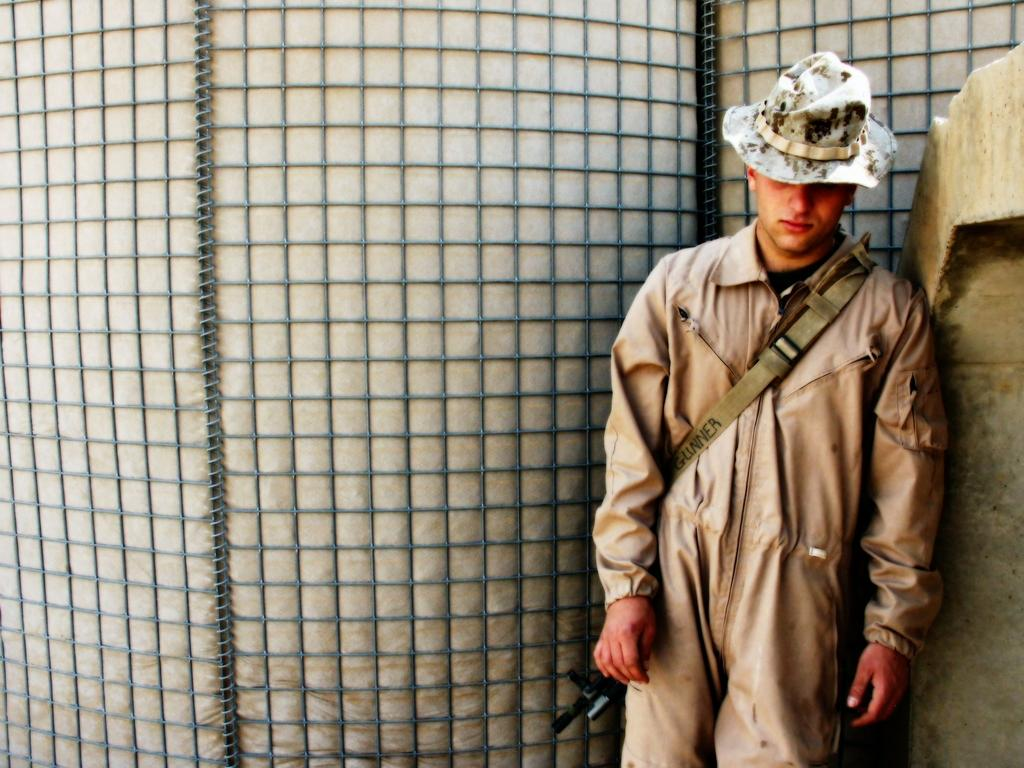Who or what is present in the image? There is a person in the image. What is the person wearing on their head? The person is wearing a hat. What can be seen on the right side of the image? There is a wall on the right side of the image. What is visible in the background of the image? There is a grill and cloth in the background of the image. What type of education does the representative in the image have? There is no representative present in the image, and therefore no information about their education can be provided. 